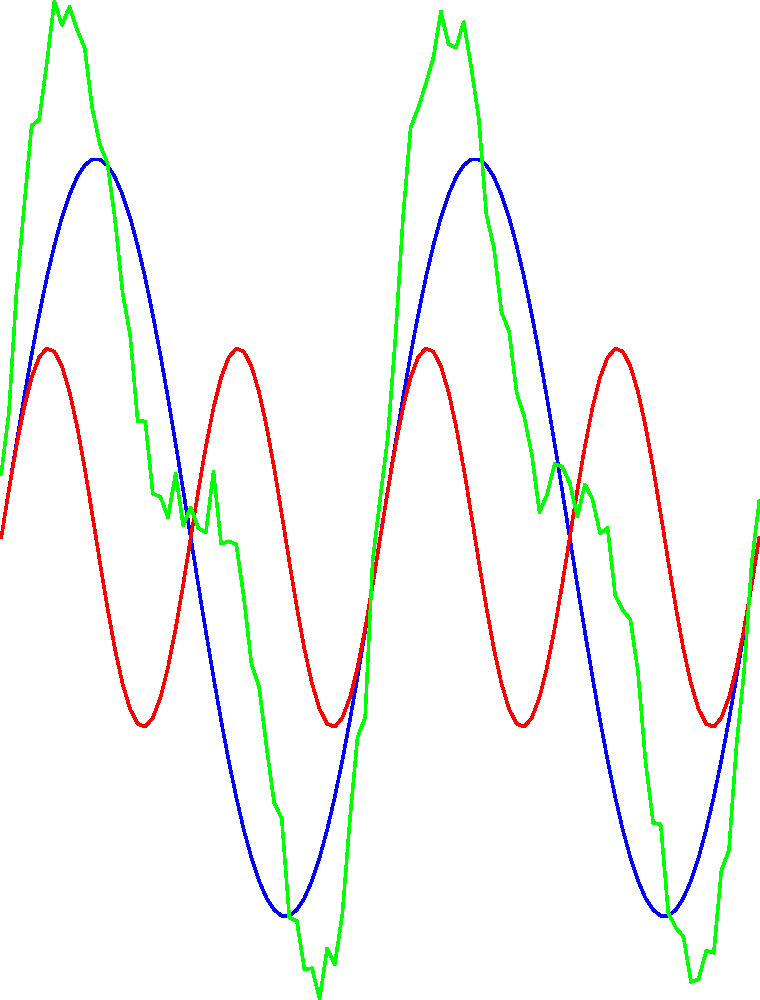In your quest to uncover hidden messages, you've intercepted a suspicious audio signal. The signal appears to be composed of random noise, but your instincts tell you there's more to it. After analyzing the waveform, you discover it's actually a combination of two hidden sine waves plus some random noise. The first hidden signal has a frequency of 1 Hz and an amplitude of 1, while the second has a frequency of 2 Hz and an amplitude of 0.5. What is the maximum possible amplitude of the combined hidden signals (without the random noise) at any given point in time? To solve this cryptographic puzzle, let's break it down step-by-step:

1) The two hidden signals can be represented as:
   Signal 1: $y_1 = \sin(2\pi x)$
   Signal 2: $y_2 = 0.5\sin(4\pi x)$

2) The combined signal (without noise) is the sum of these two:
   $y = y_1 + y_2 = \sin(2\pi x) + 0.5\sin(4\pi x)$

3) To find the maximum amplitude, we need to find the maximum possible value of $y$.

4) The maximum value of a sine function is 1, and it occurs when the argument of sine is $\frac{\pi}{2}$ or $\frac{3\pi}{2}$.

5) The maximum of $y$ will occur when both sine functions are at their maximum simultaneously.

6) For the first signal, $\sin(2\pi x)$ is at its maximum when $2\pi x = \frac{\pi}{2}$, or $x = \frac{1}{4}$.

7) For the second signal, $\sin(4\pi x)$ is at its maximum when $4\pi x = \frac{\pi}{2}$, or $x = \frac{1}{8}$.

8) These maxima coincide when $x = \frac{1}{4}$, which is when both signals will be at their peak.

9) At this point:
   $y_{max} = \sin(2\pi \cdot \frac{1}{4}) + 0.5\sin(4\pi \cdot \frac{1}{4})$
             $= \sin(\frac{\pi}{2}) + 0.5\sin(\pi)$
             $= 1 + 0.5 \cdot 0$
             $= 1$

10) Therefore, the maximum amplitude of the combined hidden signals is 1.5.
Answer: 1.5 